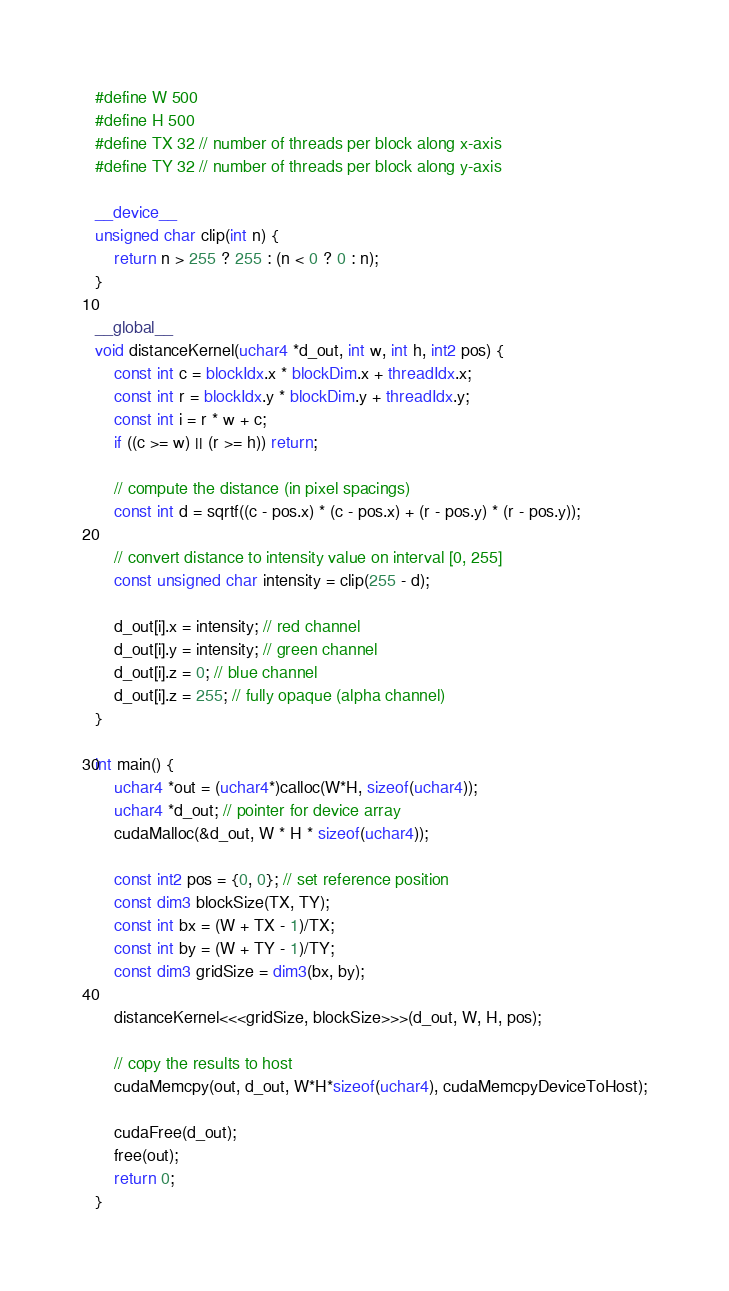<code> <loc_0><loc_0><loc_500><loc_500><_Cuda_>#define W 500
#define H 500
#define TX 32 // number of threads per block along x-axis
#define TY 32 // number of threads per block along y-axis

__device__
unsigned char clip(int n) {
    return n > 255 ? 255 : (n < 0 ? 0 : n);
}

__global__
void distanceKernel(uchar4 *d_out, int w, int h, int2 pos) {
    const int c = blockIdx.x * blockDim.x + threadIdx.x;
    const int r = blockIdx.y * blockDim.y + threadIdx.y;
    const int i = r * w + c;
    if ((c >= w) || (r >= h)) return;

    // compute the distance (in pixel spacings)
    const int d = sqrtf((c - pos.x) * (c - pos.x) + (r - pos.y) * (r - pos.y));

    // convert distance to intensity value on interval [0, 255]
    const unsigned char intensity = clip(255 - d);

    d_out[i].x = intensity; // red channel
    d_out[i].y = intensity; // green channel
    d_out[i].z = 0; // blue channel
    d_out[i].z = 255; // fully opaque (alpha channel)
}

int main() {
    uchar4 *out = (uchar4*)calloc(W*H, sizeof(uchar4));
    uchar4 *d_out; // pointer for device array
    cudaMalloc(&d_out, W * H * sizeof(uchar4));

    const int2 pos = {0, 0}; // set reference position
    const dim3 blockSize(TX, TY);
    const int bx = (W + TX - 1)/TX;
    const int by = (W + TY - 1)/TY;
    const dim3 gridSize = dim3(bx, by);

    distanceKernel<<<gridSize, blockSize>>>(d_out, W, H, pos);

    // copy the results to host
    cudaMemcpy(out, d_out, W*H*sizeof(uchar4), cudaMemcpyDeviceToHost);

    cudaFree(d_out);
    free(out);
    return 0;
}
</code> 